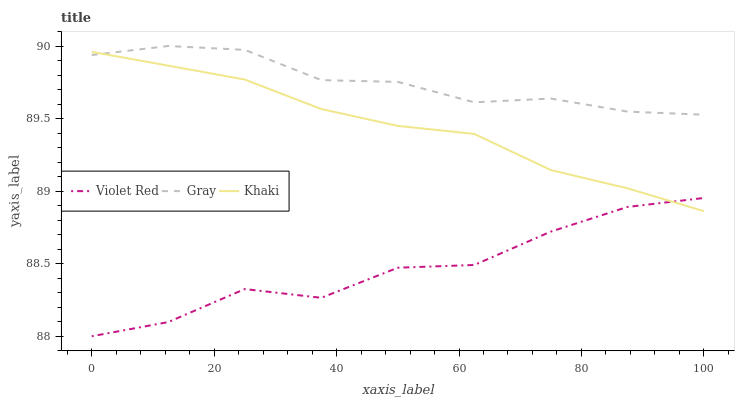Does Violet Red have the minimum area under the curve?
Answer yes or no. Yes. Does Gray have the maximum area under the curve?
Answer yes or no. Yes. Does Khaki have the minimum area under the curve?
Answer yes or no. No. Does Khaki have the maximum area under the curve?
Answer yes or no. No. Is Khaki the smoothest?
Answer yes or no. Yes. Is Violet Red the roughest?
Answer yes or no. Yes. Is Violet Red the smoothest?
Answer yes or no. No. Is Khaki the roughest?
Answer yes or no. No. Does Violet Red have the lowest value?
Answer yes or no. Yes. Does Khaki have the lowest value?
Answer yes or no. No. Does Gray have the highest value?
Answer yes or no. Yes. Does Khaki have the highest value?
Answer yes or no. No. Is Violet Red less than Gray?
Answer yes or no. Yes. Is Gray greater than Violet Red?
Answer yes or no. Yes. Does Khaki intersect Gray?
Answer yes or no. Yes. Is Khaki less than Gray?
Answer yes or no. No. Is Khaki greater than Gray?
Answer yes or no. No. Does Violet Red intersect Gray?
Answer yes or no. No. 